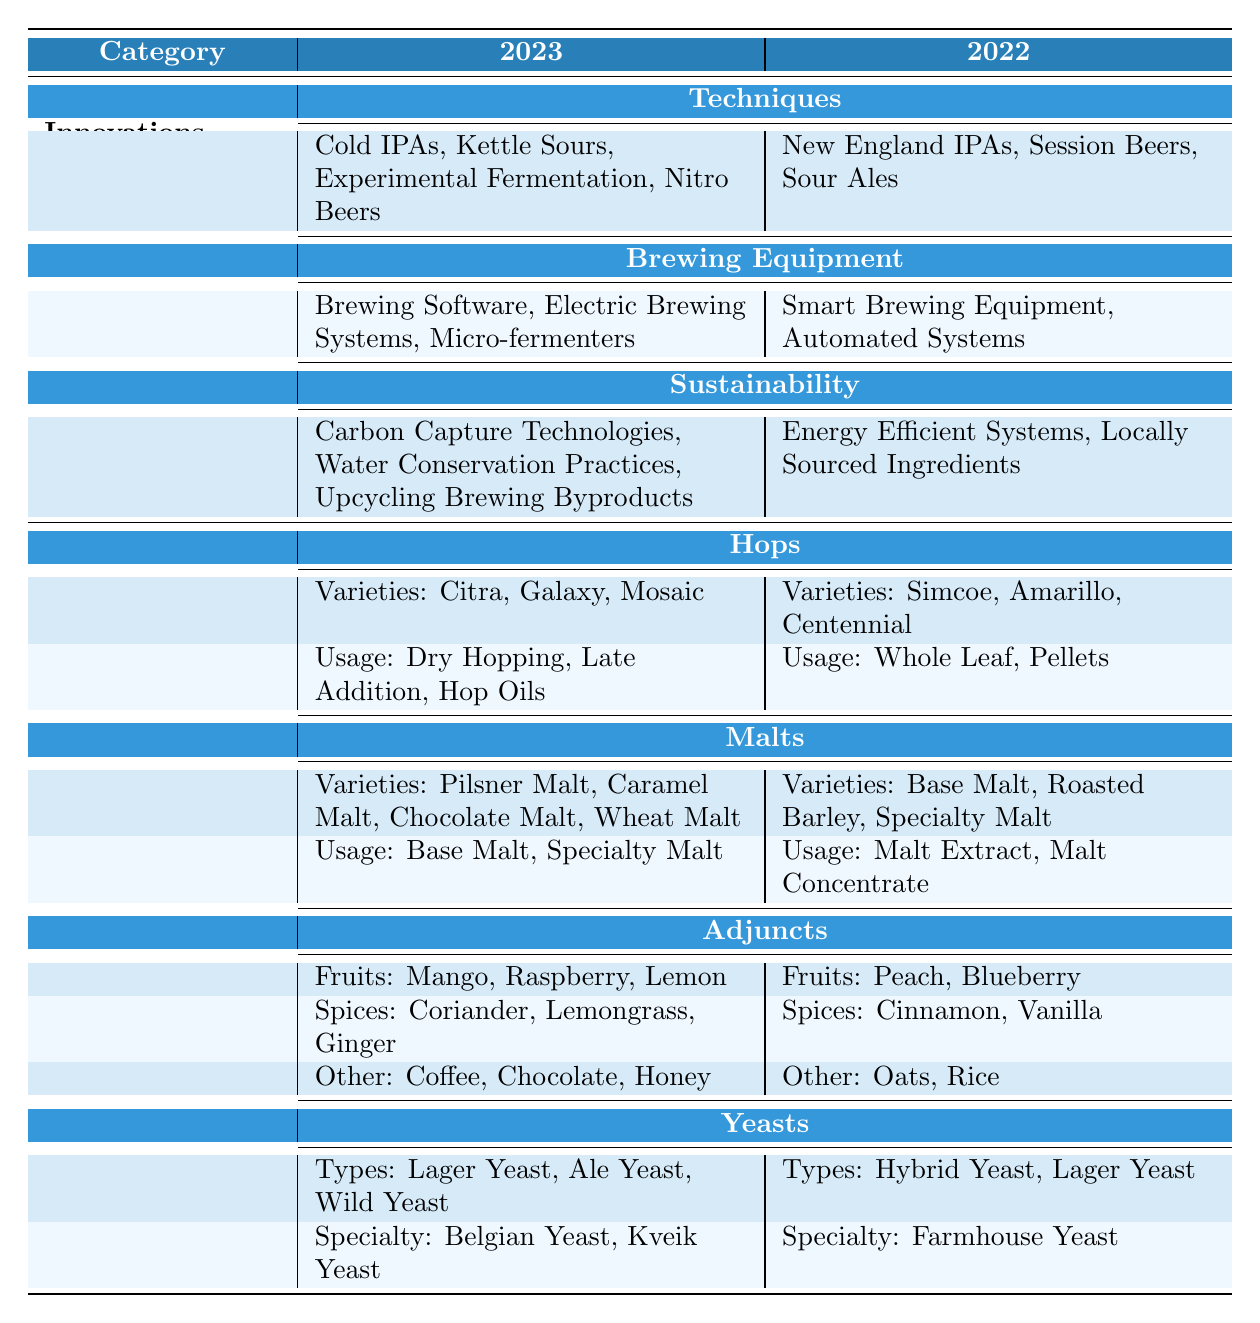What are the new brewing techniques introduced in 2023? According to the table, the innovations in brewing techniques for 2023 include Cold IPAs, Kettle Sours, Experimental Fermentation, and Nitro Beers.
Answer: Cold IPAs, Kettle Sours, Experimental Fermentation, Nitro Beers Which hops varieties were popular in 2022? The table indicates that the popular hops varieties in 2022 were Simcoe, Amarillo, and Centennial.
Answer: Simcoe, Amarillo, Centennial Are Carbon Capture Technologies used in 2022? The data shows that Carbon Capture Technologies are mentioned as an innovation for sustainability only in 2023, not in 2022.
Answer: No What is the difference in the number of malt varieties used between 2023 and 2022? In 2023, there are 4 malt varieties listed (Pilsner Malt, Caramel Malt, Chocolate Malt, Wheat Malt), while in 2022 there are 3 malt varieties (Base Malt, Roasted Barley, Specialty Malt). Thus, the difference is 4 - 3 = 1.
Answer: 1 Which year had more innovations in brewing equipment? The table lists 3 brewing equipment innovations for 2023 (Brewing Software, Electric Brewing Systems, Micro-fermenters) and 2 for 2022 (Smart Brewing Equipment, Automated Systems). Thus, 2023 had more innovations.
Answer: 2023 What types of yeast were commonly used for craft beer in 2023? In 2023, the types of yeast listed are Lager Yeast, Ale Yeast, and Wild Yeast.
Answer: Lager Yeast, Ale Yeast, Wild Yeast Did the variety of adjunct spices change from 2022 to 2023? From the table, in 2023, the spices listed are Coriander, Lemongrass, and Ginger, while in 2022, they are Cinnamon and Vanilla. Since the spices are entirely different, it indicates a change.
Answer: Yes What percentage of the 2023 popular ingredients are related to hops? In 2023, there are 3 main ingredient categories (Hops, Malts, adjuncts, Yeasts) with a total of 14 varieties mentioned across them, with 6 unique hop varieties (3 varieties + 3 usages). Thus, the percentage is (6/14) * 100% = approximately 42.86%.
Answer: 42.86% Which brewing technique introduced in 2023 is related to sustainability? The table does not list any of the brewing techniques directly as related to sustainability, as the sustainability category is separate.
Answer: None What popular fruit adjuncts are used in 2023 compared to 2022? In 2023, the popular fruit adjuncts are Mango, Raspberry, and Lemon; in 2022, they are Peach and Blueberry, showing different chosen fruits.
Answer: Mango, Raspberry, Lemon (2023) vs. Peach, Blueberry (2022) 